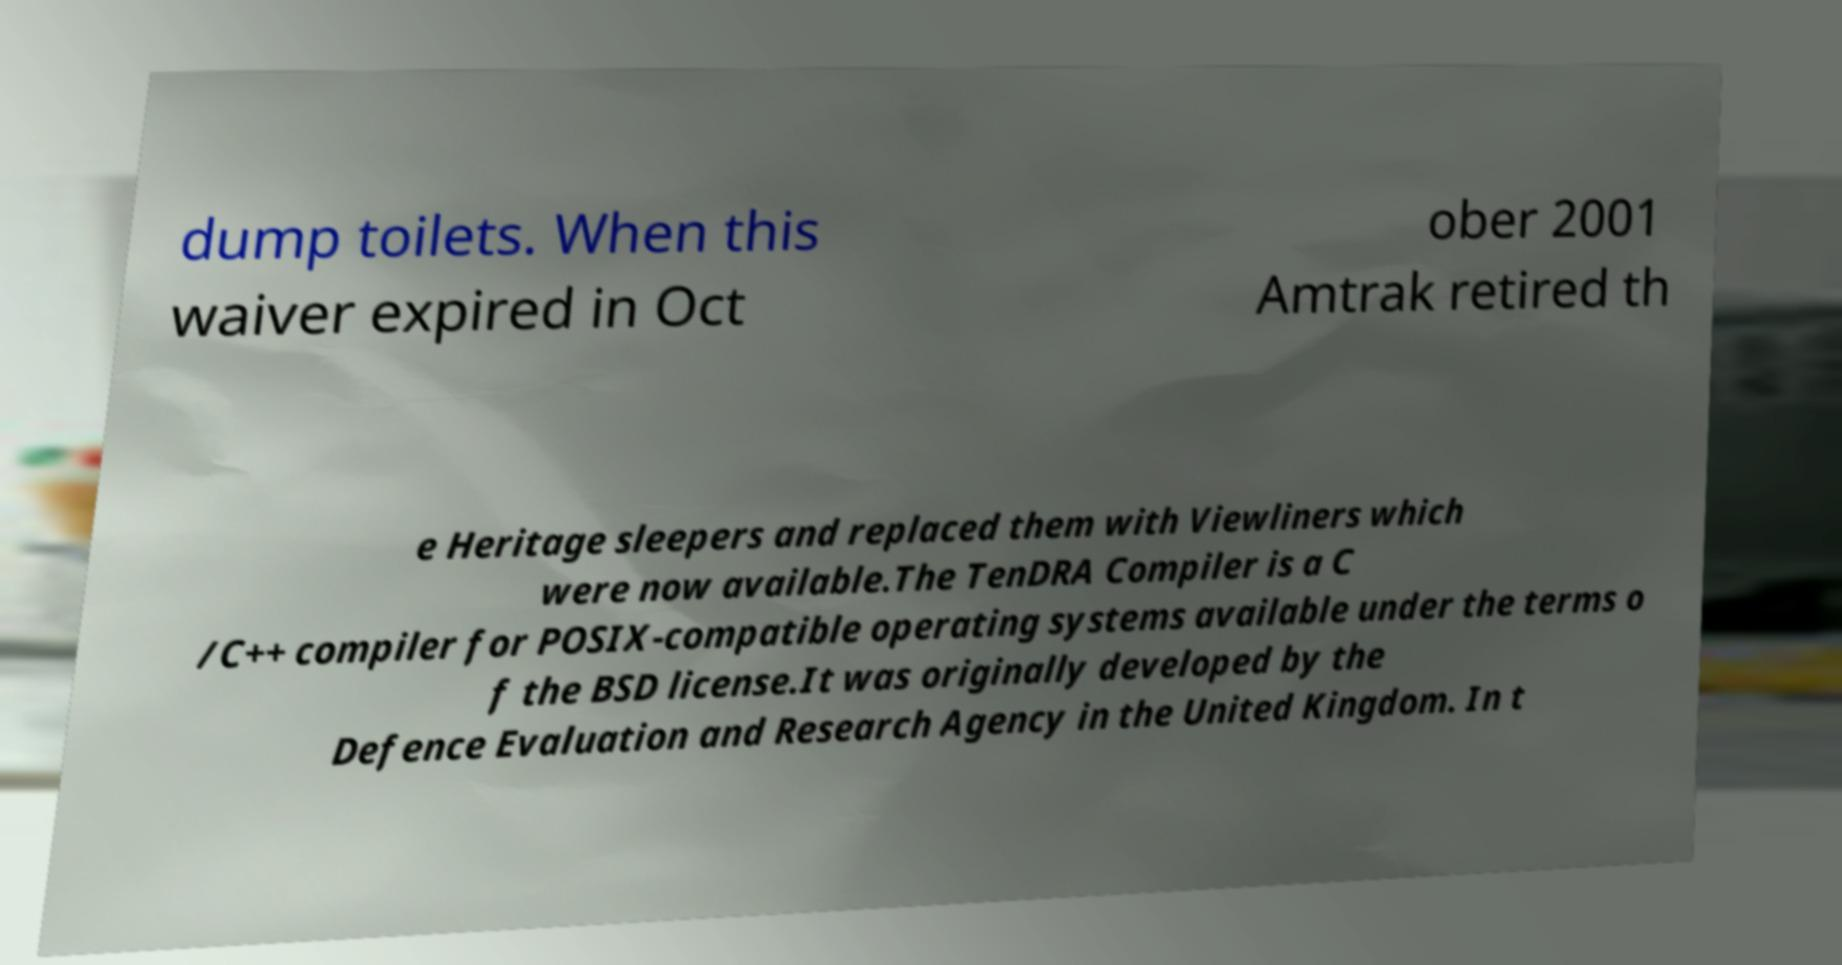What messages or text are displayed in this image? I need them in a readable, typed format. dump toilets. When this waiver expired in Oct ober 2001 Amtrak retired th e Heritage sleepers and replaced them with Viewliners which were now available.The TenDRA Compiler is a C /C++ compiler for POSIX-compatible operating systems available under the terms o f the BSD license.It was originally developed by the Defence Evaluation and Research Agency in the United Kingdom. In t 